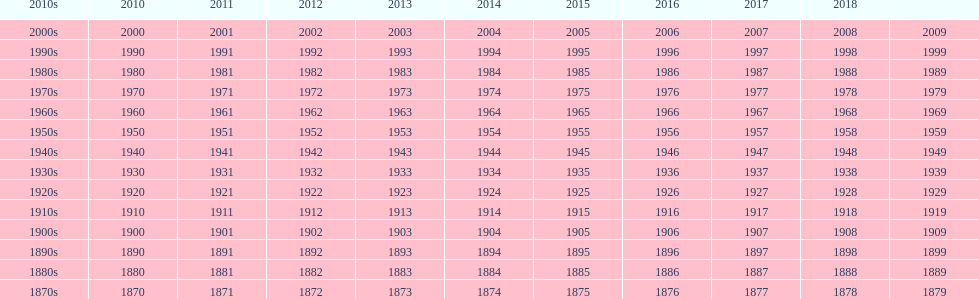Can you give me this table as a dict? {'header': ['2010s', '2010', '2011', '2012', '2013', '2014', '2015', '2016', '2017', '2018', ''], 'rows': [['2000s', '2000', '2001', '2002', '2003', '2004', '2005', '2006', '2007', '2008', '2009'], ['1990s', '1990', '1991', '1992', '1993', '1994', '1995', '1996', '1997', '1998', '1999'], ['1980s', '1980', '1981', '1982', '1983', '1984', '1985', '1986', '1987', '1988', '1989'], ['1970s', '1970', '1971', '1972', '1973', '1974', '1975', '1976', '1977', '1978', '1979'], ['1960s', '1960', '1961', '1962', '1963', '1964', '1965', '1966', '1967', '1968', '1969'], ['1950s', '1950', '1951', '1952', '1953', '1954', '1955', '1956', '1957', '1958', '1959'], ['1940s', '1940', '1941', '1942', '1943', '1944', '1945', '1946', '1947', '1948', '1949'], ['1930s', '1930', '1931', '1932', '1933', '1934', '1935', '1936', '1937', '1938', '1939'], ['1920s', '1920', '1921', '1922', '1923', '1924', '1925', '1926', '1927', '1928', '1929'], ['1910s', '1910', '1911', '1912', '1913', '1914', '1915', '1916', '1917', '1918', '1919'], ['1900s', '1900', '1901', '1902', '1903', '1904', '1905', '1906', '1907', '1908', '1909'], ['1890s', '1890', '1891', '1892', '1893', '1894', '1895', '1896', '1897', '1898', '1899'], ['1880s', '1880', '1881', '1882', '1883', '1884', '1885', '1886', '1887', '1888', '1889'], ['1870s', '1870', '1871', '1872', '1873', '1874', '1875', '1876', '1877', '1878', '1879']]} In the absence of a spot on the table, which year succeeds 2018? 2019. 